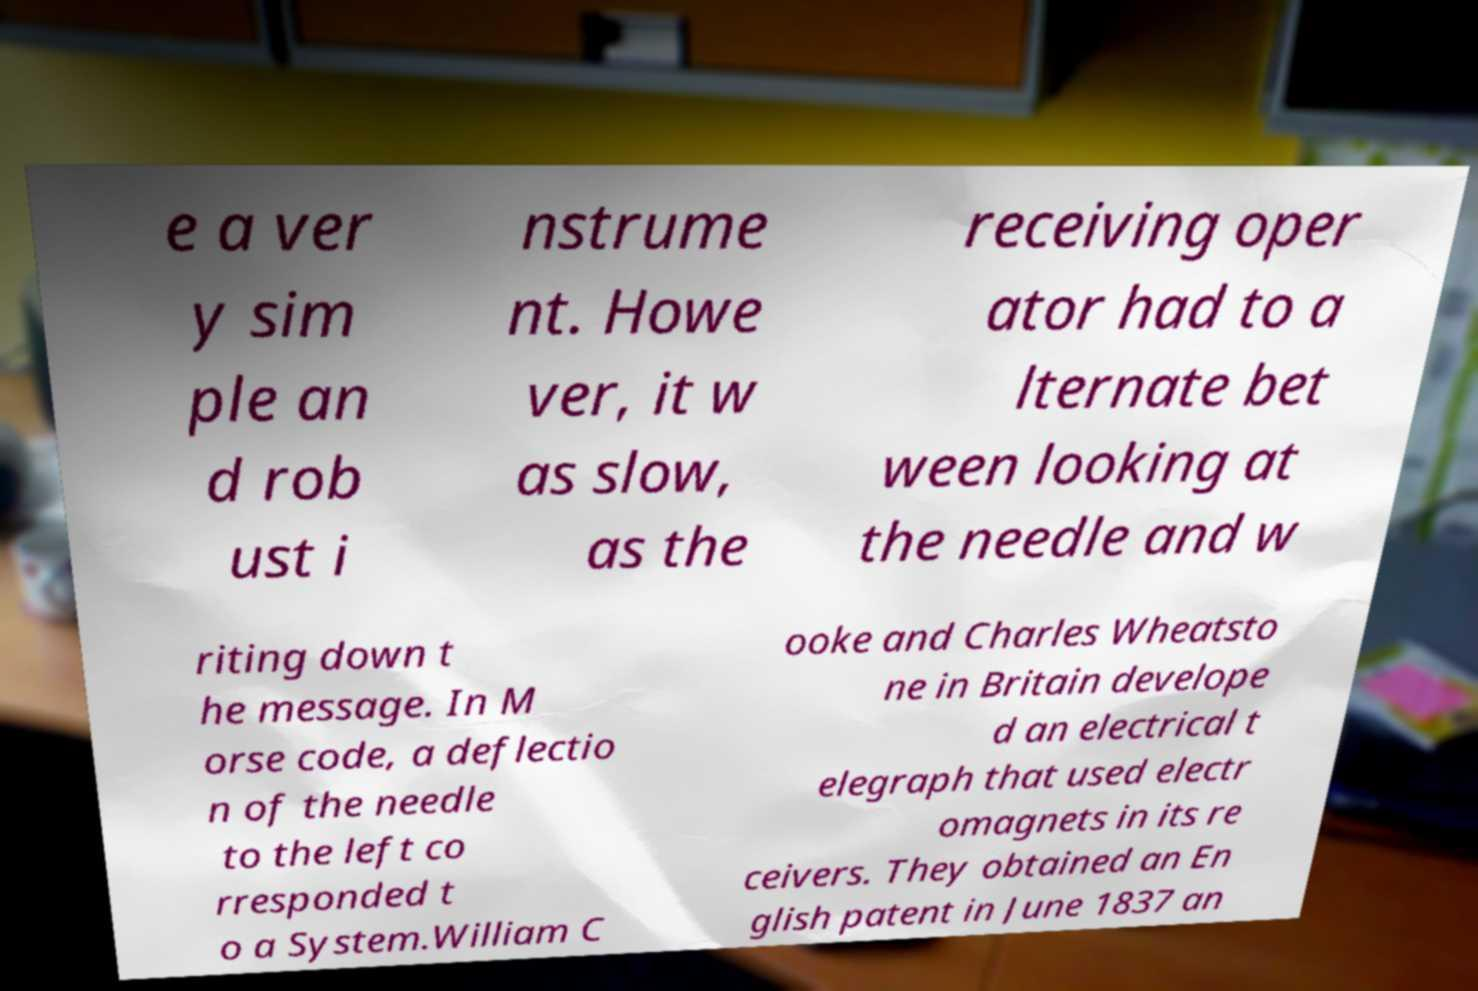For documentation purposes, I need the text within this image transcribed. Could you provide that? e a ver y sim ple an d rob ust i nstrume nt. Howe ver, it w as slow, as the receiving oper ator had to a lternate bet ween looking at the needle and w riting down t he message. In M orse code, a deflectio n of the needle to the left co rresponded t o a System.William C ooke and Charles Wheatsto ne in Britain develope d an electrical t elegraph that used electr omagnets in its re ceivers. They obtained an En glish patent in June 1837 an 